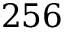Convert formula to latex. <formula><loc_0><loc_0><loc_500><loc_500>2 5 6</formula> 